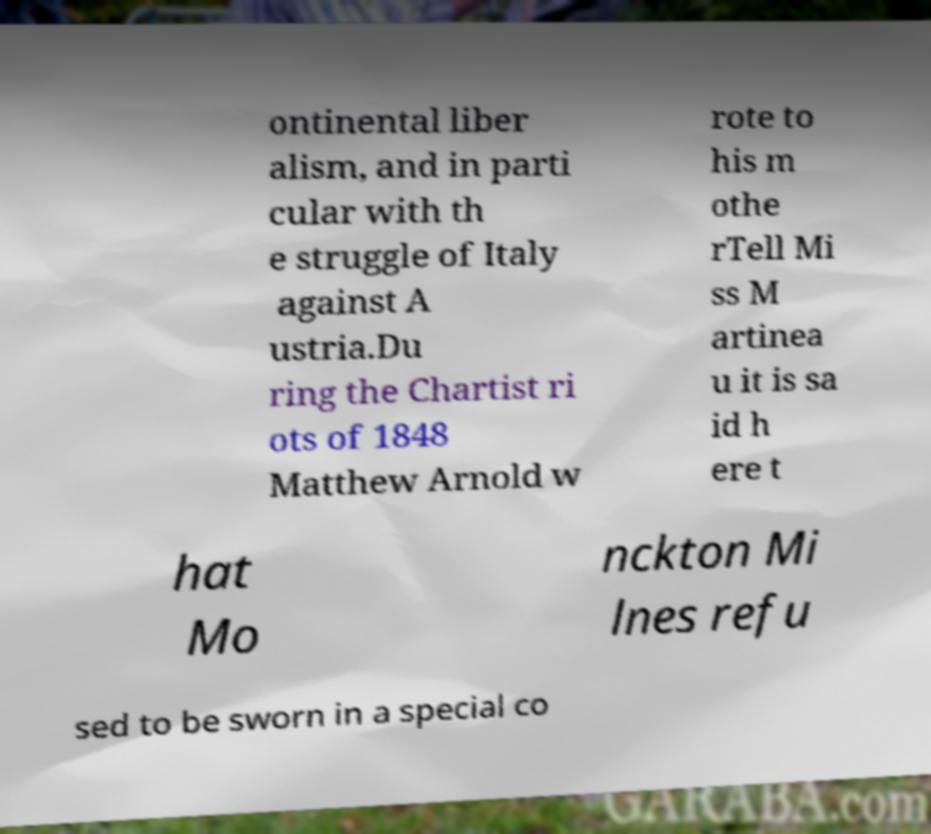What messages or text are displayed in this image? I need them in a readable, typed format. ontinental liber alism, and in parti cular with th e struggle of Italy against A ustria.Du ring the Chartist ri ots of 1848 Matthew Arnold w rote to his m othe rTell Mi ss M artinea u it is sa id h ere t hat Mo nckton Mi lnes refu sed to be sworn in a special co 